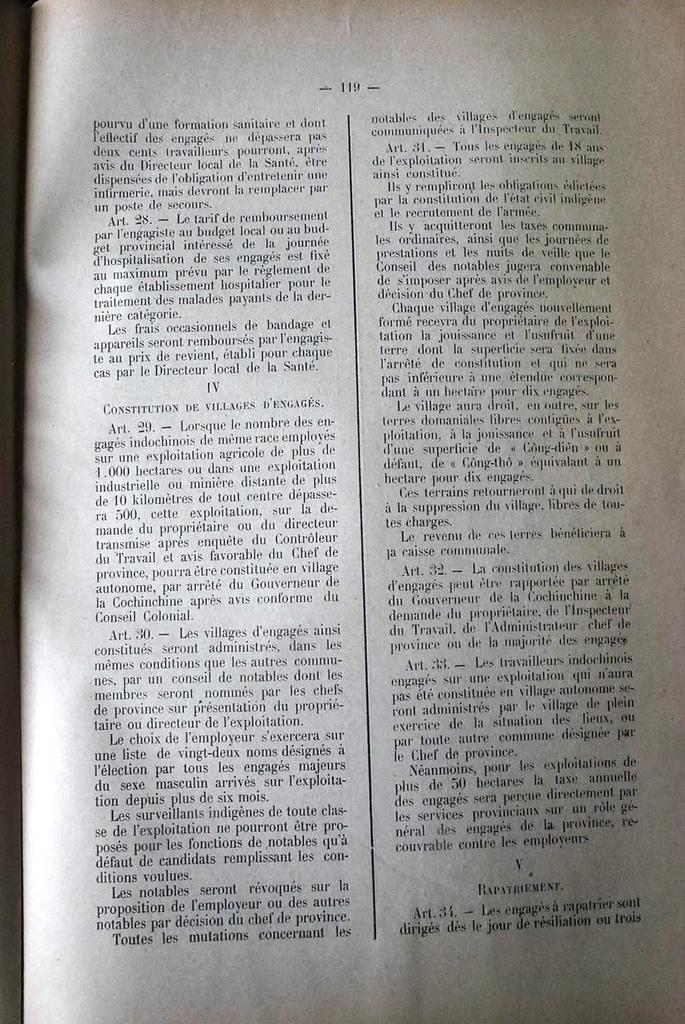<image>
Provide a brief description of the given image. A book sits open on page 119 divided by a centre line. 